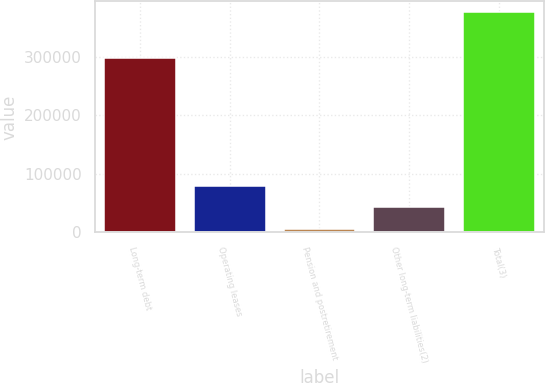Convert chart. <chart><loc_0><loc_0><loc_500><loc_500><bar_chart><fcel>Long-term debt<fcel>Operating leases<fcel>Pension and postretirement<fcel>Other long-term liabilities(2)<fcel>Total(3)<nl><fcel>297316<fcel>79782.2<fcel>5879<fcel>42830.6<fcel>375395<nl></chart> 